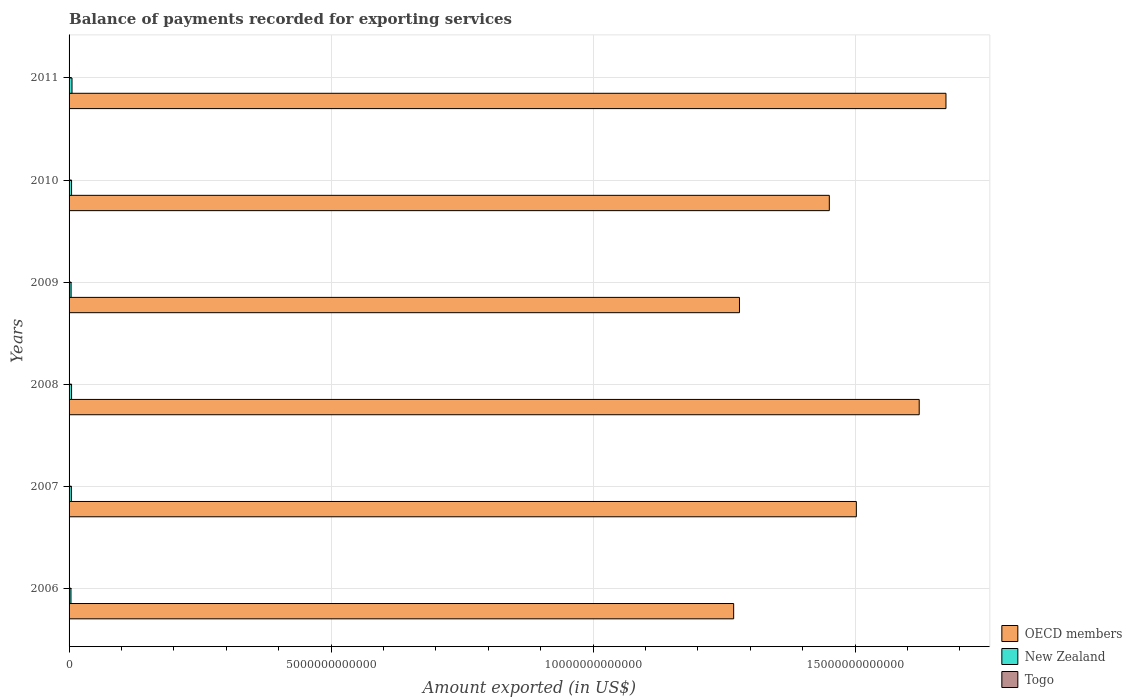How many groups of bars are there?
Give a very brief answer. 6. In how many cases, is the number of bars for a given year not equal to the number of legend labels?
Your answer should be compact. 0. What is the amount exported in New Zealand in 2010?
Ensure brevity in your answer.  4.75e+1. Across all years, what is the maximum amount exported in New Zealand?
Offer a terse response. 5.62e+1. Across all years, what is the minimum amount exported in Togo?
Provide a succinct answer. 8.79e+08. In which year was the amount exported in New Zealand maximum?
Make the answer very short. 2011. What is the total amount exported in OECD members in the graph?
Your answer should be compact. 8.80e+13. What is the difference between the amount exported in OECD members in 2007 and that in 2010?
Give a very brief answer. 5.16e+11. What is the difference between the amount exported in New Zealand in 2006 and the amount exported in Togo in 2007?
Offer a very short reply. 3.52e+1. What is the average amount exported in OECD members per year?
Provide a succinct answer. 1.47e+13. In the year 2008, what is the difference between the amount exported in OECD members and amount exported in Togo?
Your answer should be compact. 1.62e+13. What is the ratio of the amount exported in New Zealand in 2007 to that in 2010?
Your answer should be very brief. 0.93. Is the amount exported in Togo in 2006 less than that in 2007?
Your answer should be compact. Yes. Is the difference between the amount exported in OECD members in 2007 and 2010 greater than the difference between the amount exported in Togo in 2007 and 2010?
Make the answer very short. Yes. What is the difference between the highest and the second highest amount exported in New Zealand?
Your response must be concise. 8.74e+09. What is the difference between the highest and the lowest amount exported in Togo?
Offer a very short reply. 1.20e+09. Is the sum of the amount exported in New Zealand in 2006 and 2011 greater than the maximum amount exported in Togo across all years?
Give a very brief answer. Yes. What does the 3rd bar from the top in 2006 represents?
Give a very brief answer. OECD members. What does the 1st bar from the bottom in 2010 represents?
Keep it short and to the point. OECD members. Is it the case that in every year, the sum of the amount exported in OECD members and amount exported in Togo is greater than the amount exported in New Zealand?
Your response must be concise. Yes. What is the difference between two consecutive major ticks on the X-axis?
Offer a terse response. 5.00e+12. Are the values on the major ticks of X-axis written in scientific E-notation?
Your answer should be very brief. No. Does the graph contain any zero values?
Make the answer very short. No. Where does the legend appear in the graph?
Keep it short and to the point. Bottom right. How many legend labels are there?
Offer a very short reply. 3. What is the title of the graph?
Your response must be concise. Balance of payments recorded for exporting services. What is the label or title of the X-axis?
Your answer should be very brief. Amount exported (in US$). What is the label or title of the Y-axis?
Your answer should be very brief. Years. What is the Amount exported (in US$) in OECD members in 2006?
Your response must be concise. 1.27e+13. What is the Amount exported (in US$) of New Zealand in 2006?
Provide a short and direct response. 3.61e+1. What is the Amount exported (in US$) of Togo in 2006?
Your answer should be very brief. 8.79e+08. What is the Amount exported (in US$) of OECD members in 2007?
Give a very brief answer. 1.50e+13. What is the Amount exported (in US$) of New Zealand in 2007?
Your answer should be compact. 4.41e+1. What is the Amount exported (in US$) of Togo in 2007?
Keep it short and to the point. 9.74e+08. What is the Amount exported (in US$) in OECD members in 2008?
Your answer should be very brief. 1.62e+13. What is the Amount exported (in US$) in New Zealand in 2008?
Keep it short and to the point. 4.74e+1. What is the Amount exported (in US$) of Togo in 2008?
Your answer should be very brief. 1.22e+09. What is the Amount exported (in US$) of OECD members in 2009?
Your response must be concise. 1.28e+13. What is the Amount exported (in US$) of New Zealand in 2009?
Provide a short and direct response. 3.87e+1. What is the Amount exported (in US$) of Togo in 2009?
Give a very brief answer. 1.26e+09. What is the Amount exported (in US$) in OECD members in 2010?
Provide a short and direct response. 1.45e+13. What is the Amount exported (in US$) of New Zealand in 2010?
Provide a short and direct response. 4.75e+1. What is the Amount exported (in US$) of Togo in 2010?
Offer a very short reply. 1.40e+09. What is the Amount exported (in US$) in OECD members in 2011?
Your answer should be very brief. 1.67e+13. What is the Amount exported (in US$) of New Zealand in 2011?
Offer a very short reply. 5.62e+1. What is the Amount exported (in US$) in Togo in 2011?
Offer a terse response. 2.08e+09. Across all years, what is the maximum Amount exported (in US$) of OECD members?
Offer a very short reply. 1.67e+13. Across all years, what is the maximum Amount exported (in US$) of New Zealand?
Provide a succinct answer. 5.62e+1. Across all years, what is the maximum Amount exported (in US$) of Togo?
Offer a terse response. 2.08e+09. Across all years, what is the minimum Amount exported (in US$) in OECD members?
Give a very brief answer. 1.27e+13. Across all years, what is the minimum Amount exported (in US$) in New Zealand?
Keep it short and to the point. 3.61e+1. Across all years, what is the minimum Amount exported (in US$) of Togo?
Keep it short and to the point. 8.79e+08. What is the total Amount exported (in US$) of OECD members in the graph?
Your response must be concise. 8.80e+13. What is the total Amount exported (in US$) of New Zealand in the graph?
Provide a succinct answer. 2.70e+11. What is the total Amount exported (in US$) of Togo in the graph?
Offer a very short reply. 7.81e+09. What is the difference between the Amount exported (in US$) of OECD members in 2006 and that in 2007?
Your answer should be very brief. -2.34e+12. What is the difference between the Amount exported (in US$) of New Zealand in 2006 and that in 2007?
Offer a very short reply. -7.94e+09. What is the difference between the Amount exported (in US$) of Togo in 2006 and that in 2007?
Give a very brief answer. -9.53e+07. What is the difference between the Amount exported (in US$) in OECD members in 2006 and that in 2008?
Offer a terse response. -3.54e+12. What is the difference between the Amount exported (in US$) of New Zealand in 2006 and that in 2008?
Keep it short and to the point. -1.13e+1. What is the difference between the Amount exported (in US$) of Togo in 2006 and that in 2008?
Provide a short and direct response. -3.38e+08. What is the difference between the Amount exported (in US$) of OECD members in 2006 and that in 2009?
Give a very brief answer. -1.11e+11. What is the difference between the Amount exported (in US$) of New Zealand in 2006 and that in 2009?
Offer a terse response. -2.57e+09. What is the difference between the Amount exported (in US$) of Togo in 2006 and that in 2009?
Offer a very short reply. -3.86e+08. What is the difference between the Amount exported (in US$) in OECD members in 2006 and that in 2010?
Offer a very short reply. -1.83e+12. What is the difference between the Amount exported (in US$) in New Zealand in 2006 and that in 2010?
Ensure brevity in your answer.  -1.13e+1. What is the difference between the Amount exported (in US$) in Togo in 2006 and that in 2010?
Your answer should be very brief. -5.17e+08. What is the difference between the Amount exported (in US$) in OECD members in 2006 and that in 2011?
Make the answer very short. -4.05e+12. What is the difference between the Amount exported (in US$) in New Zealand in 2006 and that in 2011?
Give a very brief answer. -2.01e+1. What is the difference between the Amount exported (in US$) of Togo in 2006 and that in 2011?
Your answer should be compact. -1.20e+09. What is the difference between the Amount exported (in US$) in OECD members in 2007 and that in 2008?
Your response must be concise. -1.20e+12. What is the difference between the Amount exported (in US$) of New Zealand in 2007 and that in 2008?
Ensure brevity in your answer.  -3.35e+09. What is the difference between the Amount exported (in US$) of Togo in 2007 and that in 2008?
Ensure brevity in your answer.  -2.43e+08. What is the difference between the Amount exported (in US$) in OECD members in 2007 and that in 2009?
Your answer should be very brief. 2.23e+12. What is the difference between the Amount exported (in US$) in New Zealand in 2007 and that in 2009?
Your response must be concise. 5.36e+09. What is the difference between the Amount exported (in US$) in Togo in 2007 and that in 2009?
Your answer should be very brief. -2.91e+08. What is the difference between the Amount exported (in US$) in OECD members in 2007 and that in 2010?
Give a very brief answer. 5.16e+11. What is the difference between the Amount exported (in US$) of New Zealand in 2007 and that in 2010?
Your answer should be compact. -3.40e+09. What is the difference between the Amount exported (in US$) in Togo in 2007 and that in 2010?
Offer a very short reply. -4.22e+08. What is the difference between the Amount exported (in US$) in OECD members in 2007 and that in 2011?
Keep it short and to the point. -1.71e+12. What is the difference between the Amount exported (in US$) in New Zealand in 2007 and that in 2011?
Your answer should be compact. -1.21e+1. What is the difference between the Amount exported (in US$) of Togo in 2007 and that in 2011?
Ensure brevity in your answer.  -1.10e+09. What is the difference between the Amount exported (in US$) of OECD members in 2008 and that in 2009?
Keep it short and to the point. 3.43e+12. What is the difference between the Amount exported (in US$) of New Zealand in 2008 and that in 2009?
Make the answer very short. 8.71e+09. What is the difference between the Amount exported (in US$) in Togo in 2008 and that in 2009?
Offer a very short reply. -4.82e+07. What is the difference between the Amount exported (in US$) of OECD members in 2008 and that in 2010?
Offer a very short reply. 1.72e+12. What is the difference between the Amount exported (in US$) of New Zealand in 2008 and that in 2010?
Your answer should be compact. -5.45e+07. What is the difference between the Amount exported (in US$) of Togo in 2008 and that in 2010?
Your answer should be very brief. -1.79e+08. What is the difference between the Amount exported (in US$) in OECD members in 2008 and that in 2011?
Provide a short and direct response. -5.11e+11. What is the difference between the Amount exported (in US$) of New Zealand in 2008 and that in 2011?
Your answer should be very brief. -8.79e+09. What is the difference between the Amount exported (in US$) in Togo in 2008 and that in 2011?
Offer a terse response. -8.62e+08. What is the difference between the Amount exported (in US$) of OECD members in 2009 and that in 2010?
Offer a terse response. -1.71e+12. What is the difference between the Amount exported (in US$) in New Zealand in 2009 and that in 2010?
Provide a short and direct response. -8.76e+09. What is the difference between the Amount exported (in US$) in Togo in 2009 and that in 2010?
Keep it short and to the point. -1.31e+08. What is the difference between the Amount exported (in US$) of OECD members in 2009 and that in 2011?
Provide a short and direct response. -3.94e+12. What is the difference between the Amount exported (in US$) in New Zealand in 2009 and that in 2011?
Make the answer very short. -1.75e+1. What is the difference between the Amount exported (in US$) of Togo in 2009 and that in 2011?
Your answer should be compact. -8.14e+08. What is the difference between the Amount exported (in US$) in OECD members in 2010 and that in 2011?
Offer a terse response. -2.23e+12. What is the difference between the Amount exported (in US$) of New Zealand in 2010 and that in 2011?
Provide a succinct answer. -8.74e+09. What is the difference between the Amount exported (in US$) in Togo in 2010 and that in 2011?
Offer a very short reply. -6.83e+08. What is the difference between the Amount exported (in US$) in OECD members in 2006 and the Amount exported (in US$) in New Zealand in 2007?
Provide a short and direct response. 1.26e+13. What is the difference between the Amount exported (in US$) of OECD members in 2006 and the Amount exported (in US$) of Togo in 2007?
Provide a short and direct response. 1.27e+13. What is the difference between the Amount exported (in US$) of New Zealand in 2006 and the Amount exported (in US$) of Togo in 2007?
Provide a succinct answer. 3.52e+1. What is the difference between the Amount exported (in US$) of OECD members in 2006 and the Amount exported (in US$) of New Zealand in 2008?
Provide a succinct answer. 1.26e+13. What is the difference between the Amount exported (in US$) of OECD members in 2006 and the Amount exported (in US$) of Togo in 2008?
Offer a terse response. 1.27e+13. What is the difference between the Amount exported (in US$) of New Zealand in 2006 and the Amount exported (in US$) of Togo in 2008?
Your answer should be very brief. 3.49e+1. What is the difference between the Amount exported (in US$) of OECD members in 2006 and the Amount exported (in US$) of New Zealand in 2009?
Ensure brevity in your answer.  1.26e+13. What is the difference between the Amount exported (in US$) in OECD members in 2006 and the Amount exported (in US$) in Togo in 2009?
Ensure brevity in your answer.  1.27e+13. What is the difference between the Amount exported (in US$) in New Zealand in 2006 and the Amount exported (in US$) in Togo in 2009?
Offer a terse response. 3.49e+1. What is the difference between the Amount exported (in US$) in OECD members in 2006 and the Amount exported (in US$) in New Zealand in 2010?
Ensure brevity in your answer.  1.26e+13. What is the difference between the Amount exported (in US$) in OECD members in 2006 and the Amount exported (in US$) in Togo in 2010?
Offer a very short reply. 1.27e+13. What is the difference between the Amount exported (in US$) in New Zealand in 2006 and the Amount exported (in US$) in Togo in 2010?
Provide a short and direct response. 3.47e+1. What is the difference between the Amount exported (in US$) of OECD members in 2006 and the Amount exported (in US$) of New Zealand in 2011?
Provide a succinct answer. 1.26e+13. What is the difference between the Amount exported (in US$) of OECD members in 2006 and the Amount exported (in US$) of Togo in 2011?
Offer a terse response. 1.27e+13. What is the difference between the Amount exported (in US$) of New Zealand in 2006 and the Amount exported (in US$) of Togo in 2011?
Offer a terse response. 3.41e+1. What is the difference between the Amount exported (in US$) of OECD members in 2007 and the Amount exported (in US$) of New Zealand in 2008?
Give a very brief answer. 1.50e+13. What is the difference between the Amount exported (in US$) in OECD members in 2007 and the Amount exported (in US$) in Togo in 2008?
Make the answer very short. 1.50e+13. What is the difference between the Amount exported (in US$) in New Zealand in 2007 and the Amount exported (in US$) in Togo in 2008?
Offer a very short reply. 4.29e+1. What is the difference between the Amount exported (in US$) in OECD members in 2007 and the Amount exported (in US$) in New Zealand in 2009?
Give a very brief answer. 1.50e+13. What is the difference between the Amount exported (in US$) in OECD members in 2007 and the Amount exported (in US$) in Togo in 2009?
Ensure brevity in your answer.  1.50e+13. What is the difference between the Amount exported (in US$) in New Zealand in 2007 and the Amount exported (in US$) in Togo in 2009?
Keep it short and to the point. 4.28e+1. What is the difference between the Amount exported (in US$) in OECD members in 2007 and the Amount exported (in US$) in New Zealand in 2010?
Ensure brevity in your answer.  1.50e+13. What is the difference between the Amount exported (in US$) of OECD members in 2007 and the Amount exported (in US$) of Togo in 2010?
Ensure brevity in your answer.  1.50e+13. What is the difference between the Amount exported (in US$) in New Zealand in 2007 and the Amount exported (in US$) in Togo in 2010?
Make the answer very short. 4.27e+1. What is the difference between the Amount exported (in US$) of OECD members in 2007 and the Amount exported (in US$) of New Zealand in 2011?
Make the answer very short. 1.50e+13. What is the difference between the Amount exported (in US$) in OECD members in 2007 and the Amount exported (in US$) in Togo in 2011?
Your response must be concise. 1.50e+13. What is the difference between the Amount exported (in US$) of New Zealand in 2007 and the Amount exported (in US$) of Togo in 2011?
Your response must be concise. 4.20e+1. What is the difference between the Amount exported (in US$) of OECD members in 2008 and the Amount exported (in US$) of New Zealand in 2009?
Ensure brevity in your answer.  1.62e+13. What is the difference between the Amount exported (in US$) of OECD members in 2008 and the Amount exported (in US$) of Togo in 2009?
Make the answer very short. 1.62e+13. What is the difference between the Amount exported (in US$) of New Zealand in 2008 and the Amount exported (in US$) of Togo in 2009?
Your answer should be compact. 4.62e+1. What is the difference between the Amount exported (in US$) in OECD members in 2008 and the Amount exported (in US$) in New Zealand in 2010?
Give a very brief answer. 1.62e+13. What is the difference between the Amount exported (in US$) of OECD members in 2008 and the Amount exported (in US$) of Togo in 2010?
Give a very brief answer. 1.62e+13. What is the difference between the Amount exported (in US$) in New Zealand in 2008 and the Amount exported (in US$) in Togo in 2010?
Provide a succinct answer. 4.60e+1. What is the difference between the Amount exported (in US$) in OECD members in 2008 and the Amount exported (in US$) in New Zealand in 2011?
Provide a short and direct response. 1.62e+13. What is the difference between the Amount exported (in US$) of OECD members in 2008 and the Amount exported (in US$) of Togo in 2011?
Your answer should be compact. 1.62e+13. What is the difference between the Amount exported (in US$) of New Zealand in 2008 and the Amount exported (in US$) of Togo in 2011?
Keep it short and to the point. 4.53e+1. What is the difference between the Amount exported (in US$) of OECD members in 2009 and the Amount exported (in US$) of New Zealand in 2010?
Make the answer very short. 1.27e+13. What is the difference between the Amount exported (in US$) of OECD members in 2009 and the Amount exported (in US$) of Togo in 2010?
Make the answer very short. 1.28e+13. What is the difference between the Amount exported (in US$) of New Zealand in 2009 and the Amount exported (in US$) of Togo in 2010?
Provide a succinct answer. 3.73e+1. What is the difference between the Amount exported (in US$) of OECD members in 2009 and the Amount exported (in US$) of New Zealand in 2011?
Your response must be concise. 1.27e+13. What is the difference between the Amount exported (in US$) in OECD members in 2009 and the Amount exported (in US$) in Togo in 2011?
Your answer should be very brief. 1.28e+13. What is the difference between the Amount exported (in US$) of New Zealand in 2009 and the Amount exported (in US$) of Togo in 2011?
Your response must be concise. 3.66e+1. What is the difference between the Amount exported (in US$) in OECD members in 2010 and the Amount exported (in US$) in New Zealand in 2011?
Give a very brief answer. 1.45e+13. What is the difference between the Amount exported (in US$) of OECD members in 2010 and the Amount exported (in US$) of Togo in 2011?
Offer a very short reply. 1.45e+13. What is the difference between the Amount exported (in US$) in New Zealand in 2010 and the Amount exported (in US$) in Togo in 2011?
Keep it short and to the point. 4.54e+1. What is the average Amount exported (in US$) of OECD members per year?
Offer a very short reply. 1.47e+13. What is the average Amount exported (in US$) in New Zealand per year?
Make the answer very short. 4.50e+1. What is the average Amount exported (in US$) in Togo per year?
Your response must be concise. 1.30e+09. In the year 2006, what is the difference between the Amount exported (in US$) of OECD members and Amount exported (in US$) of New Zealand?
Make the answer very short. 1.26e+13. In the year 2006, what is the difference between the Amount exported (in US$) of OECD members and Amount exported (in US$) of Togo?
Your answer should be compact. 1.27e+13. In the year 2006, what is the difference between the Amount exported (in US$) of New Zealand and Amount exported (in US$) of Togo?
Your response must be concise. 3.53e+1. In the year 2007, what is the difference between the Amount exported (in US$) in OECD members and Amount exported (in US$) in New Zealand?
Provide a short and direct response. 1.50e+13. In the year 2007, what is the difference between the Amount exported (in US$) in OECD members and Amount exported (in US$) in Togo?
Give a very brief answer. 1.50e+13. In the year 2007, what is the difference between the Amount exported (in US$) of New Zealand and Amount exported (in US$) of Togo?
Offer a very short reply. 4.31e+1. In the year 2008, what is the difference between the Amount exported (in US$) in OECD members and Amount exported (in US$) in New Zealand?
Offer a very short reply. 1.62e+13. In the year 2008, what is the difference between the Amount exported (in US$) of OECD members and Amount exported (in US$) of Togo?
Ensure brevity in your answer.  1.62e+13. In the year 2008, what is the difference between the Amount exported (in US$) of New Zealand and Amount exported (in US$) of Togo?
Offer a very short reply. 4.62e+1. In the year 2009, what is the difference between the Amount exported (in US$) of OECD members and Amount exported (in US$) of New Zealand?
Provide a succinct answer. 1.28e+13. In the year 2009, what is the difference between the Amount exported (in US$) of OECD members and Amount exported (in US$) of Togo?
Ensure brevity in your answer.  1.28e+13. In the year 2009, what is the difference between the Amount exported (in US$) of New Zealand and Amount exported (in US$) of Togo?
Your answer should be compact. 3.74e+1. In the year 2010, what is the difference between the Amount exported (in US$) of OECD members and Amount exported (in US$) of New Zealand?
Make the answer very short. 1.45e+13. In the year 2010, what is the difference between the Amount exported (in US$) of OECD members and Amount exported (in US$) of Togo?
Ensure brevity in your answer.  1.45e+13. In the year 2010, what is the difference between the Amount exported (in US$) of New Zealand and Amount exported (in US$) of Togo?
Provide a short and direct response. 4.61e+1. In the year 2011, what is the difference between the Amount exported (in US$) in OECD members and Amount exported (in US$) in New Zealand?
Give a very brief answer. 1.67e+13. In the year 2011, what is the difference between the Amount exported (in US$) of OECD members and Amount exported (in US$) of Togo?
Make the answer very short. 1.67e+13. In the year 2011, what is the difference between the Amount exported (in US$) in New Zealand and Amount exported (in US$) in Togo?
Make the answer very short. 5.41e+1. What is the ratio of the Amount exported (in US$) in OECD members in 2006 to that in 2007?
Make the answer very short. 0.84. What is the ratio of the Amount exported (in US$) of New Zealand in 2006 to that in 2007?
Your answer should be very brief. 0.82. What is the ratio of the Amount exported (in US$) of Togo in 2006 to that in 2007?
Your response must be concise. 0.9. What is the ratio of the Amount exported (in US$) of OECD members in 2006 to that in 2008?
Make the answer very short. 0.78. What is the ratio of the Amount exported (in US$) of New Zealand in 2006 to that in 2008?
Offer a terse response. 0.76. What is the ratio of the Amount exported (in US$) in Togo in 2006 to that in 2008?
Offer a terse response. 0.72. What is the ratio of the Amount exported (in US$) in OECD members in 2006 to that in 2009?
Keep it short and to the point. 0.99. What is the ratio of the Amount exported (in US$) of New Zealand in 2006 to that in 2009?
Provide a short and direct response. 0.93. What is the ratio of the Amount exported (in US$) in Togo in 2006 to that in 2009?
Your answer should be compact. 0.69. What is the ratio of the Amount exported (in US$) in OECD members in 2006 to that in 2010?
Make the answer very short. 0.87. What is the ratio of the Amount exported (in US$) in New Zealand in 2006 to that in 2010?
Make the answer very short. 0.76. What is the ratio of the Amount exported (in US$) in Togo in 2006 to that in 2010?
Your answer should be very brief. 0.63. What is the ratio of the Amount exported (in US$) in OECD members in 2006 to that in 2011?
Provide a succinct answer. 0.76. What is the ratio of the Amount exported (in US$) of New Zealand in 2006 to that in 2011?
Offer a very short reply. 0.64. What is the ratio of the Amount exported (in US$) in Togo in 2006 to that in 2011?
Make the answer very short. 0.42. What is the ratio of the Amount exported (in US$) of OECD members in 2007 to that in 2008?
Make the answer very short. 0.93. What is the ratio of the Amount exported (in US$) of New Zealand in 2007 to that in 2008?
Offer a very short reply. 0.93. What is the ratio of the Amount exported (in US$) of Togo in 2007 to that in 2008?
Your response must be concise. 0.8. What is the ratio of the Amount exported (in US$) in OECD members in 2007 to that in 2009?
Provide a succinct answer. 1.17. What is the ratio of the Amount exported (in US$) of New Zealand in 2007 to that in 2009?
Give a very brief answer. 1.14. What is the ratio of the Amount exported (in US$) of Togo in 2007 to that in 2009?
Your response must be concise. 0.77. What is the ratio of the Amount exported (in US$) in OECD members in 2007 to that in 2010?
Ensure brevity in your answer.  1.04. What is the ratio of the Amount exported (in US$) in New Zealand in 2007 to that in 2010?
Provide a succinct answer. 0.93. What is the ratio of the Amount exported (in US$) of Togo in 2007 to that in 2010?
Your response must be concise. 0.7. What is the ratio of the Amount exported (in US$) in OECD members in 2007 to that in 2011?
Offer a terse response. 0.9. What is the ratio of the Amount exported (in US$) in New Zealand in 2007 to that in 2011?
Give a very brief answer. 0.78. What is the ratio of the Amount exported (in US$) in Togo in 2007 to that in 2011?
Your answer should be very brief. 0.47. What is the ratio of the Amount exported (in US$) in OECD members in 2008 to that in 2009?
Your answer should be very brief. 1.27. What is the ratio of the Amount exported (in US$) in New Zealand in 2008 to that in 2009?
Give a very brief answer. 1.23. What is the ratio of the Amount exported (in US$) of Togo in 2008 to that in 2009?
Ensure brevity in your answer.  0.96. What is the ratio of the Amount exported (in US$) in OECD members in 2008 to that in 2010?
Offer a terse response. 1.12. What is the ratio of the Amount exported (in US$) in Togo in 2008 to that in 2010?
Give a very brief answer. 0.87. What is the ratio of the Amount exported (in US$) of OECD members in 2008 to that in 2011?
Make the answer very short. 0.97. What is the ratio of the Amount exported (in US$) of New Zealand in 2008 to that in 2011?
Offer a terse response. 0.84. What is the ratio of the Amount exported (in US$) of Togo in 2008 to that in 2011?
Provide a succinct answer. 0.59. What is the ratio of the Amount exported (in US$) of OECD members in 2009 to that in 2010?
Provide a short and direct response. 0.88. What is the ratio of the Amount exported (in US$) in New Zealand in 2009 to that in 2010?
Your answer should be compact. 0.82. What is the ratio of the Amount exported (in US$) of Togo in 2009 to that in 2010?
Your response must be concise. 0.91. What is the ratio of the Amount exported (in US$) of OECD members in 2009 to that in 2011?
Offer a terse response. 0.76. What is the ratio of the Amount exported (in US$) in New Zealand in 2009 to that in 2011?
Provide a short and direct response. 0.69. What is the ratio of the Amount exported (in US$) in Togo in 2009 to that in 2011?
Your answer should be very brief. 0.61. What is the ratio of the Amount exported (in US$) of OECD members in 2010 to that in 2011?
Provide a succinct answer. 0.87. What is the ratio of the Amount exported (in US$) of New Zealand in 2010 to that in 2011?
Offer a very short reply. 0.84. What is the ratio of the Amount exported (in US$) in Togo in 2010 to that in 2011?
Your answer should be compact. 0.67. What is the difference between the highest and the second highest Amount exported (in US$) of OECD members?
Keep it short and to the point. 5.11e+11. What is the difference between the highest and the second highest Amount exported (in US$) in New Zealand?
Provide a succinct answer. 8.74e+09. What is the difference between the highest and the second highest Amount exported (in US$) of Togo?
Your answer should be very brief. 6.83e+08. What is the difference between the highest and the lowest Amount exported (in US$) of OECD members?
Offer a terse response. 4.05e+12. What is the difference between the highest and the lowest Amount exported (in US$) in New Zealand?
Offer a terse response. 2.01e+1. What is the difference between the highest and the lowest Amount exported (in US$) in Togo?
Your response must be concise. 1.20e+09. 